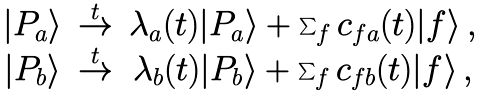Convert formula to latex. <formula><loc_0><loc_0><loc_500><loc_500>\begin{array} { c c c } | P _ { a } \rangle & \stackrel { t } { \to } & \lambda _ { a } ( t ) | P _ { a } \rangle + \sum _ { f } c _ { f a } ( t ) | f \rangle \, , \\ | P _ { b } \rangle & \stackrel { t } { \to } & \lambda _ { b } ( t ) | P _ { b } \rangle + \sum _ { f } c _ { f b } ( t ) | f \rangle \, , \end{array}</formula> 